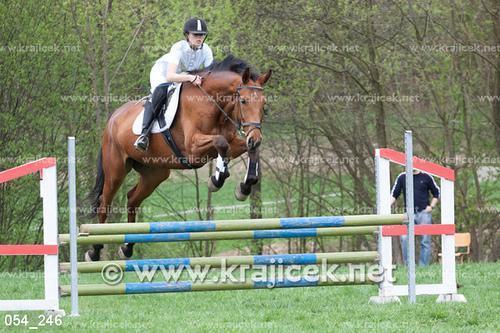How many horses are in the picture?
Give a very brief answer. 1. How many white horses are there?
Give a very brief answer. 0. 